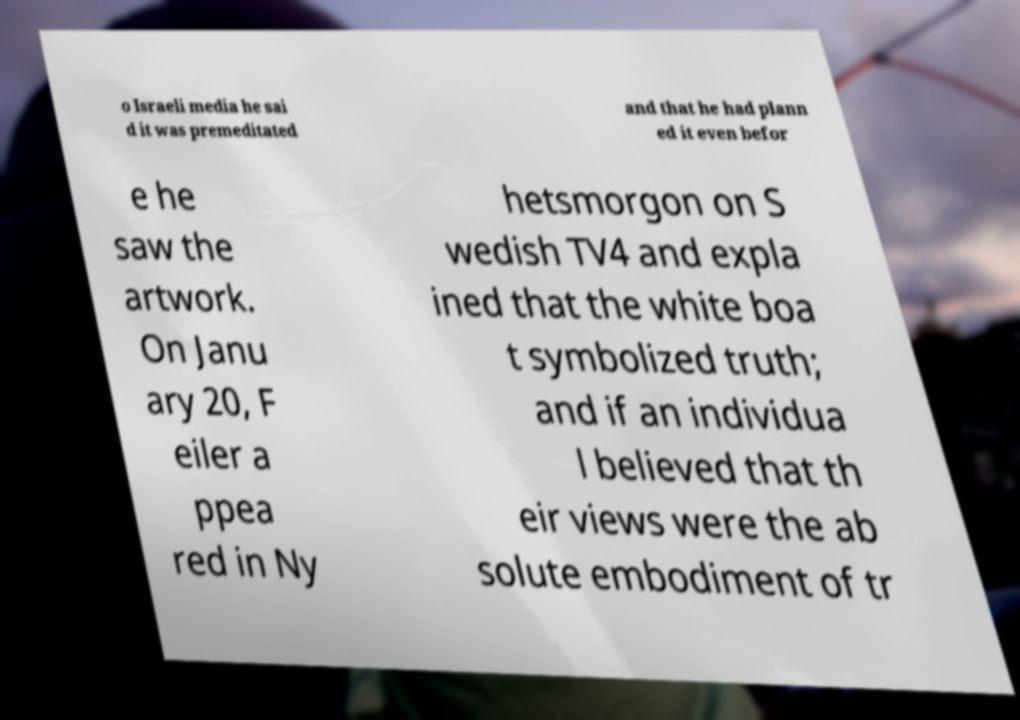Can you accurately transcribe the text from the provided image for me? o Israeli media he sai d it was premeditated and that he had plann ed it even befor e he saw the artwork. On Janu ary 20, F eiler a ppea red in Ny hetsmorgon on S wedish TV4 and expla ined that the white boa t symbolized truth; and if an individua l believed that th eir views were the ab solute embodiment of tr 